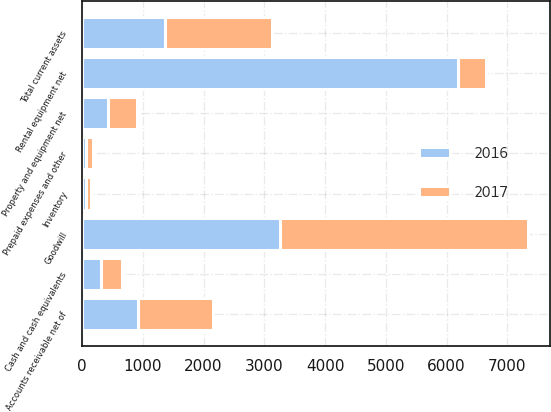Convert chart to OTSL. <chart><loc_0><loc_0><loc_500><loc_500><stacked_bar_chart><ecel><fcel>Cash and cash equivalents<fcel>Accounts receivable net of<fcel>Inventory<fcel>Prepaid expenses and other<fcel>Total current assets<fcel>Rental equipment net<fcel>Property and equipment net<fcel>Goodwill<nl><fcel>2017<fcel>352<fcel>1233<fcel>75<fcel>112<fcel>1772<fcel>467<fcel>467<fcel>4082<nl><fcel>2016<fcel>312<fcel>920<fcel>68<fcel>61<fcel>1361<fcel>6189<fcel>430<fcel>3260<nl></chart> 